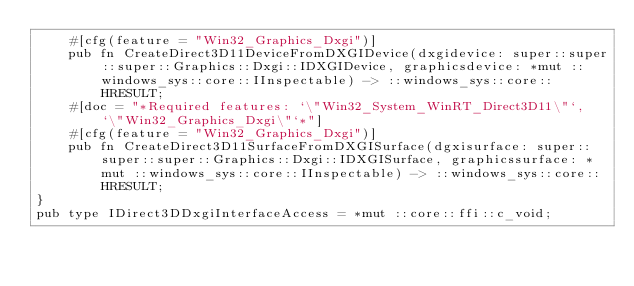<code> <loc_0><loc_0><loc_500><loc_500><_Rust_>    #[cfg(feature = "Win32_Graphics_Dxgi")]
    pub fn CreateDirect3D11DeviceFromDXGIDevice(dxgidevice: super::super::super::Graphics::Dxgi::IDXGIDevice, graphicsdevice: *mut ::windows_sys::core::IInspectable) -> ::windows_sys::core::HRESULT;
    #[doc = "*Required features: `\"Win32_System_WinRT_Direct3D11\"`, `\"Win32_Graphics_Dxgi\"`*"]
    #[cfg(feature = "Win32_Graphics_Dxgi")]
    pub fn CreateDirect3D11SurfaceFromDXGISurface(dgxisurface: super::super::super::Graphics::Dxgi::IDXGISurface, graphicssurface: *mut ::windows_sys::core::IInspectable) -> ::windows_sys::core::HRESULT;
}
pub type IDirect3DDxgiInterfaceAccess = *mut ::core::ffi::c_void;
</code> 